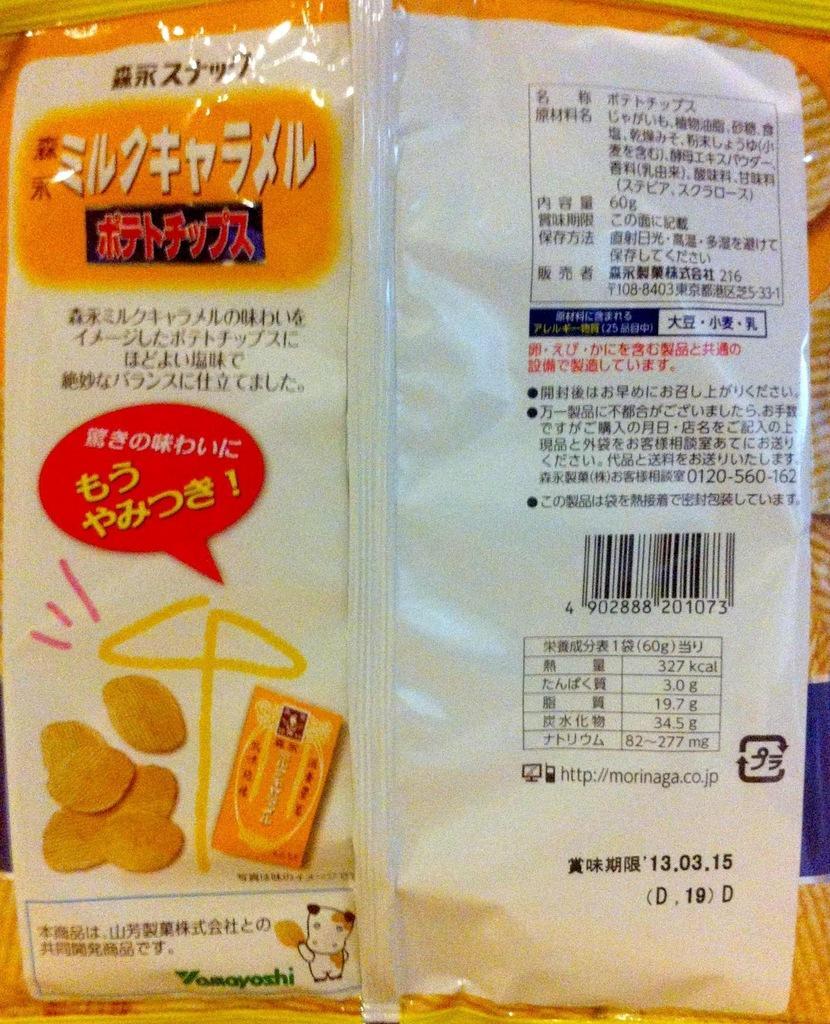In one or two sentences, can you explain what this image depicts? In this image, we can see a cover. On the cover, we can see some pictures and text written on it. 